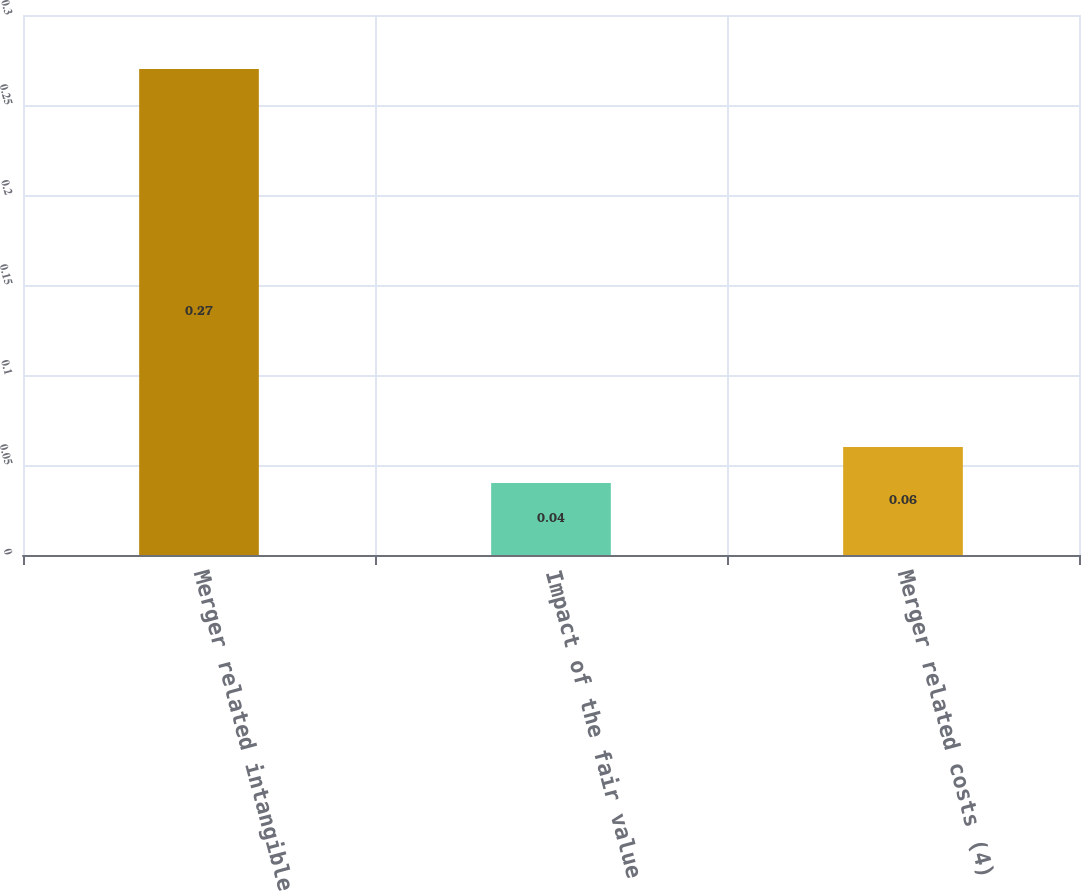Convert chart to OTSL. <chart><loc_0><loc_0><loc_500><loc_500><bar_chart><fcel>Merger related intangible<fcel>Impact of the fair value<fcel>Merger related costs (4)<nl><fcel>0.27<fcel>0.04<fcel>0.06<nl></chart> 